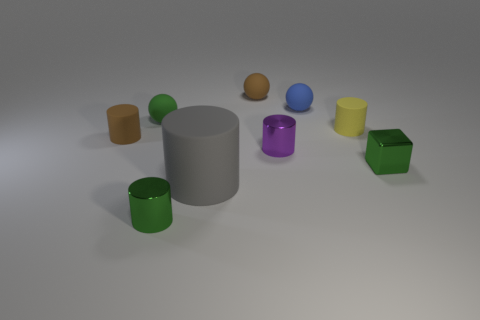How many small green metallic objects are behind the gray rubber thing to the left of the blue matte object? 1 